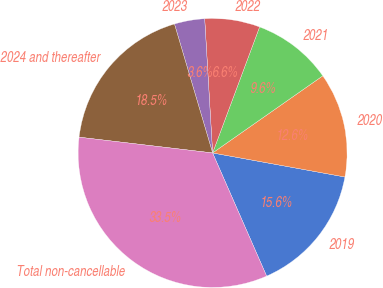<chart> <loc_0><loc_0><loc_500><loc_500><pie_chart><fcel>2019<fcel>2020<fcel>2021<fcel>2022<fcel>2023<fcel>2024 and thereafter<fcel>Total non-cancellable<nl><fcel>15.56%<fcel>12.58%<fcel>9.6%<fcel>6.62%<fcel>3.64%<fcel>18.55%<fcel>33.45%<nl></chart> 